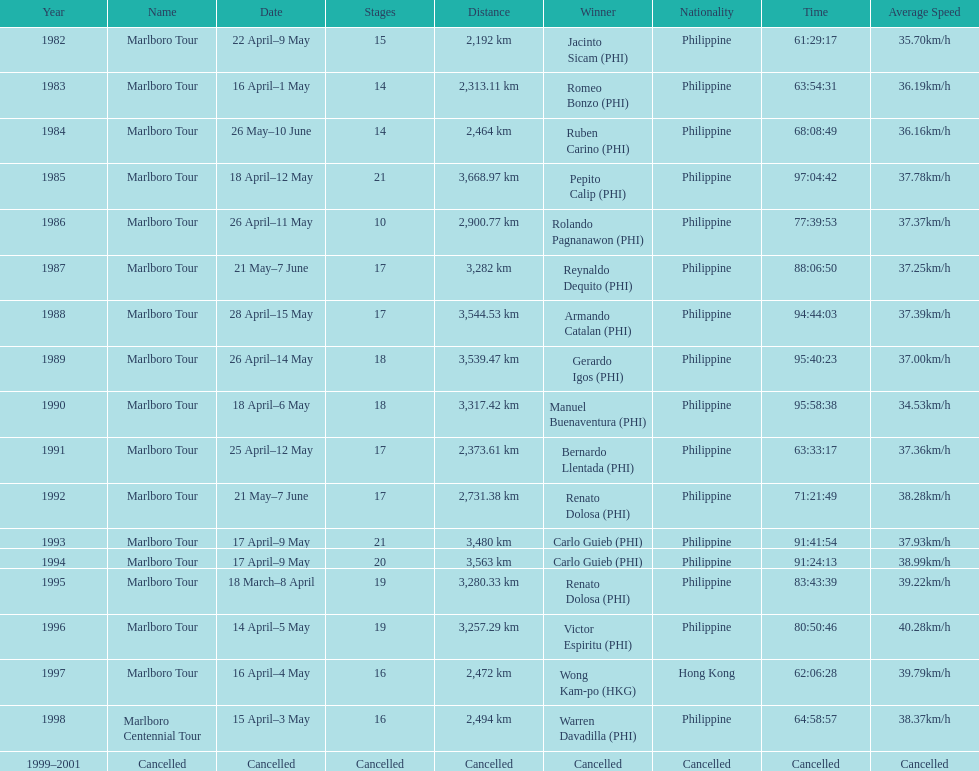How long did it take warren davadilla to complete the 1998 marlboro centennial tour? 64:58:57. 